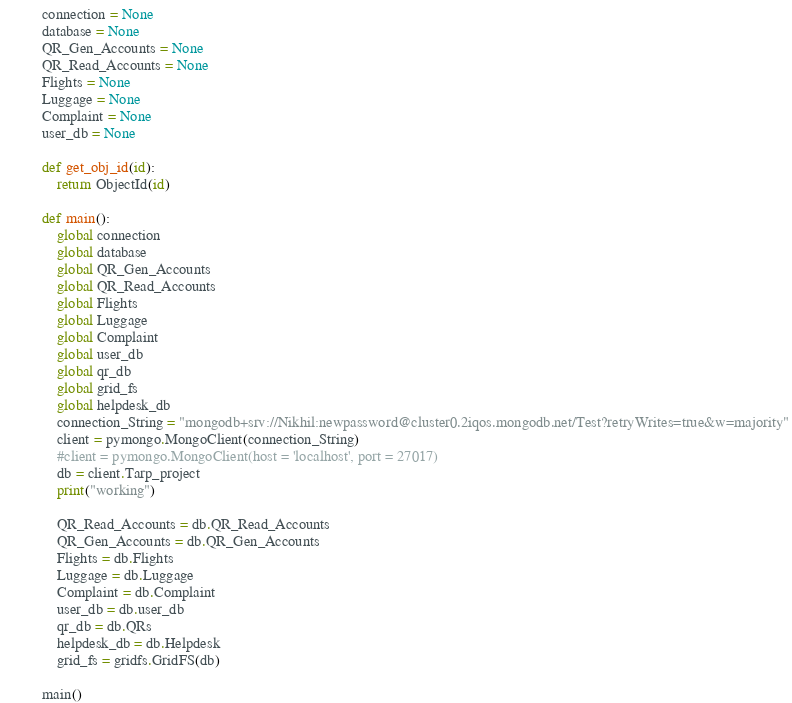Convert code to text. <code><loc_0><loc_0><loc_500><loc_500><_Python_>connection = None
database = None
QR_Gen_Accounts = None
QR_Read_Accounts = None
Flights = None
Luggage = None
Complaint = None
user_db = None

def get_obj_id(id):
    return ObjectId(id)

def main():
    global connection
    global database
    global QR_Gen_Accounts
    global QR_Read_Accounts
    global Flights
    global Luggage
    global Complaint
    global user_db
    global qr_db
    global grid_fs
    global helpdesk_db
    connection_String = "mongodb+srv://Nikhil:newpassword@cluster0.2iqos.mongodb.net/Test?retryWrites=true&w=majority"
    client = pymongo.MongoClient(connection_String)
    #client = pymongo.MongoClient(host = 'localhost', port = 27017)
    db = client.Tarp_project
    print("working")
    
    QR_Read_Accounts = db.QR_Read_Accounts
    QR_Gen_Accounts = db.QR_Gen_Accounts
    Flights = db.Flights
    Luggage = db.Luggage
    Complaint = db.Complaint
    user_db = db.user_db
    qr_db = db.QRs
    helpdesk_db = db.Helpdesk
    grid_fs = gridfs.GridFS(db)

main()</code> 